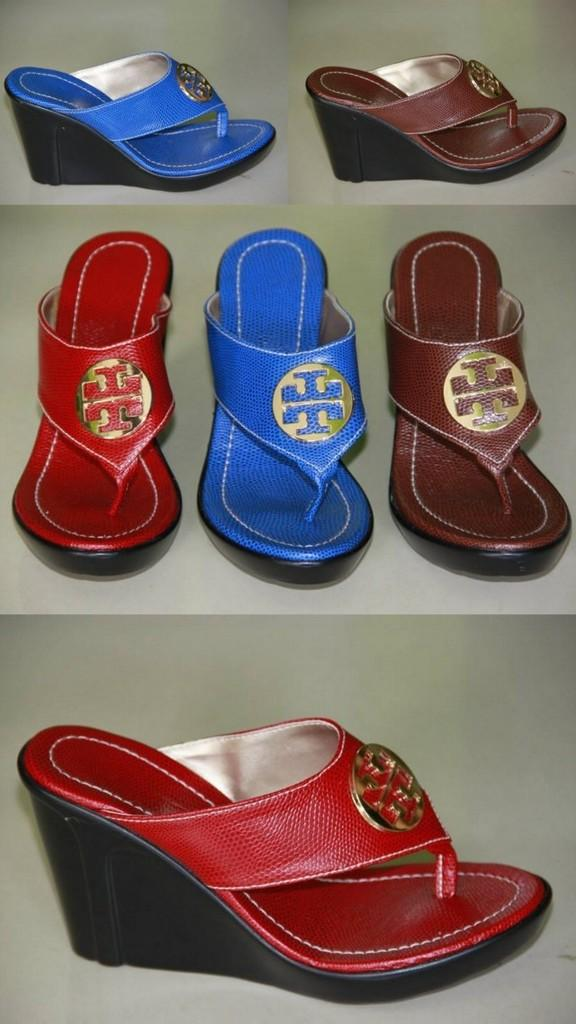What type of object can be seen in the image? There is footwear in the image. How many beggars can be seen in the image? There are no beggars present in the image; it only features footwear. What type of teeth can be seen on the pizzas in the image? There are no pizzas or teeth present in the image; it only features footwear. 